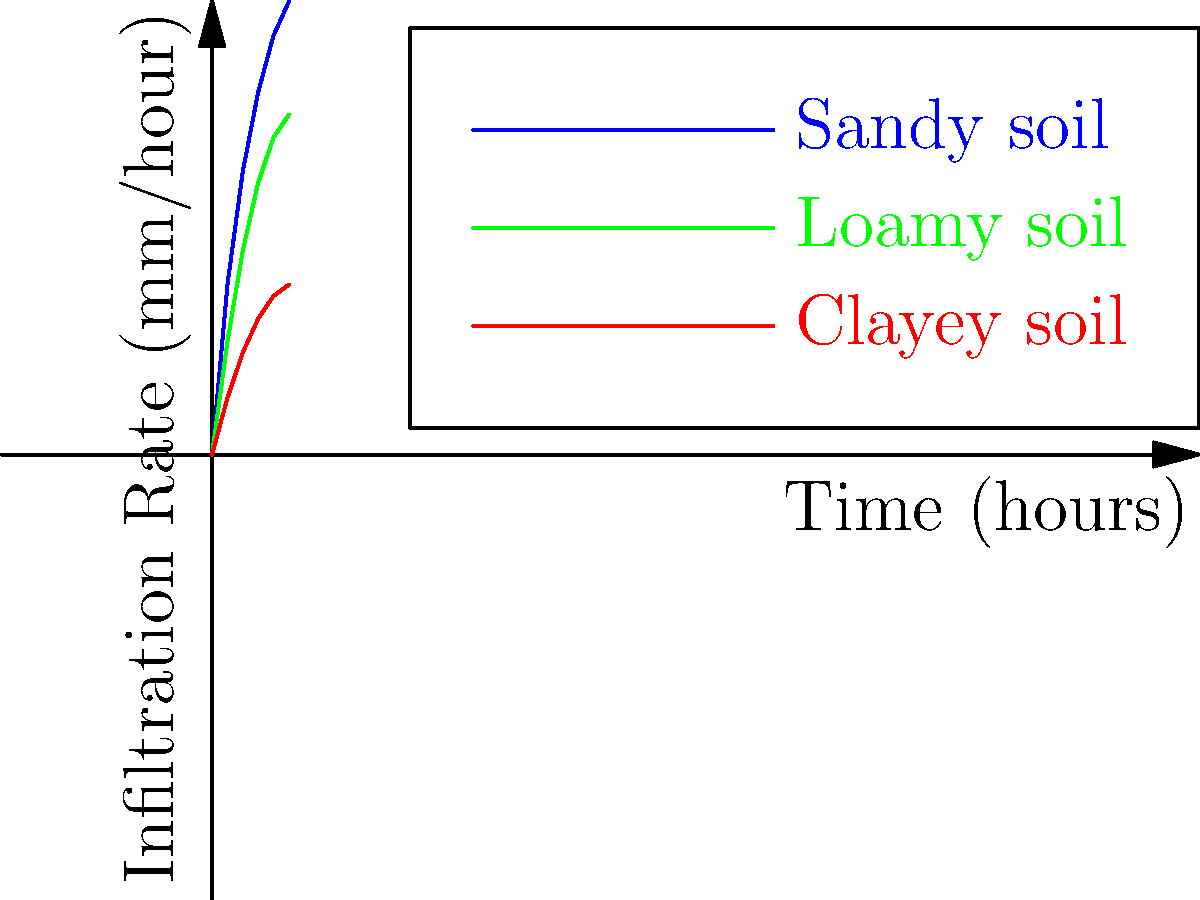Analyze the infiltration rate diagrams for sandy, loamy, and clayey forest soils. Which soil type demonstrates the highest water retention capability, and how does this impact sustainable forest management practices? To determine which soil type has the highest water retention capability, we need to analyze the infiltration rate diagrams:

1. Sandy soil (blue line):
   - Starts with the highest infiltration rate
   - Reaches about 40 mm/hour after 5 hours
   - Steep initial curve, then flattens out

2. Loamy soil (green line):
   - Starts with a moderate infiltration rate
   - Reaches about 30 mm/hour after 5 hours
   - Moderate initial curve, then gradual increase

3. Clayey soil (red line):
   - Starts with the lowest infiltration rate
   - Reaches about 15 mm/hour after 5 hours
   - Gradual increase throughout the time period

Water retention capability is inversely related to infiltration rate. A lower infiltration rate indicates higher water retention:

- Clayey soil has the lowest infiltration rate, meaning it retains water the best.
- Loamy soil has a moderate infiltration rate and moderate water retention.
- Sandy soil has the highest infiltration rate and lowest water retention.

Impact on sustainable forest management:

1. Soil water retention affects plant growth and forest productivity.
2. Clayey soils may require less frequent irrigation but can be prone to waterlogging.
3. Sandy soils may need more frequent irrigation and are at higher risk of drought stress.
4. Loamy soils offer a balance between water retention and drainage.
5. Forest managers should consider soil type when planning species selection, irrigation strategies, and erosion control measures.
6. Understanding soil water retention helps in designing effective water conservation practices and maintaining forest health.
Answer: Clayey soil; highest water retention impacts irrigation needs, species selection, and water conservation strategies in forest management. 